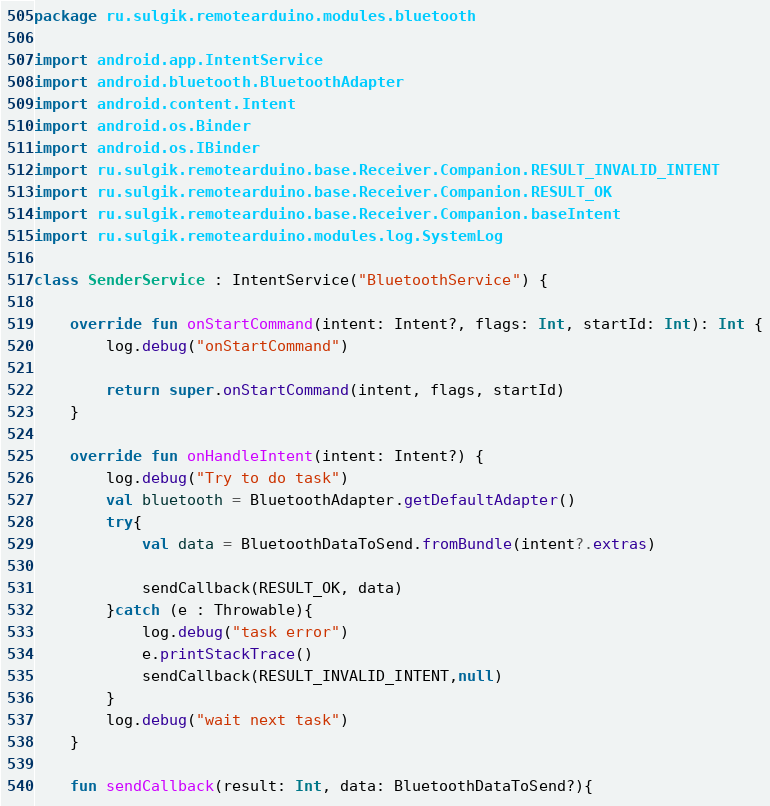<code> <loc_0><loc_0><loc_500><loc_500><_Kotlin_>package ru.sulgik.remotearduino.modules.bluetooth

import android.app.IntentService
import android.bluetooth.BluetoothAdapter
import android.content.Intent
import android.os.Binder
import android.os.IBinder
import ru.sulgik.remotearduino.base.Receiver.Companion.RESULT_INVALID_INTENT
import ru.sulgik.remotearduino.base.Receiver.Companion.RESULT_OK
import ru.sulgik.remotearduino.base.Receiver.Companion.baseIntent
import ru.sulgik.remotearduino.modules.log.SystemLog

class SenderService : IntentService("BluetoothService") {

    override fun onStartCommand(intent: Intent?, flags: Int, startId: Int): Int {
        log.debug("onStartCommand")

        return super.onStartCommand(intent, flags, startId)
    }

    override fun onHandleIntent(intent: Intent?) {
        log.debug("Try to do task")
        val bluetooth = BluetoothAdapter.getDefaultAdapter()
        try{
            val data = BluetoothDataToSend.fromBundle(intent?.extras)

            sendCallback(RESULT_OK, data)
        }catch (e : Throwable){
            log.debug("task error")
            e.printStackTrace()
            sendCallback(RESULT_INVALID_INTENT,null)
        }
        log.debug("wait next task")
    }

    fun sendCallback(result: Int, data: BluetoothDataToSend?){</code> 